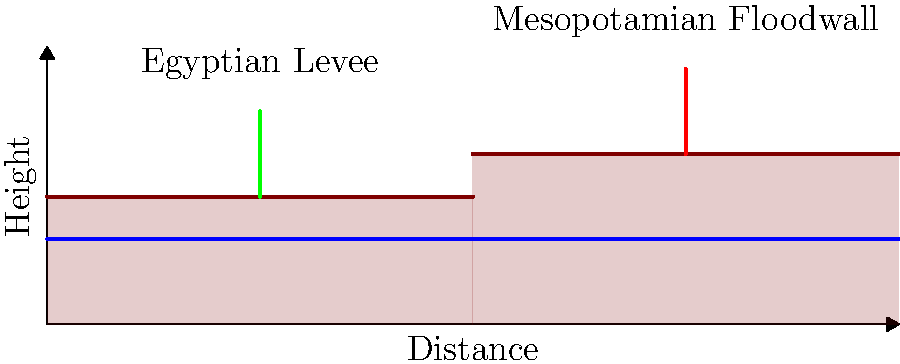Based on the cross-sectional diagram comparing flood control methods of ancient Egyptian and Mesopotamian civilizations, which method appears to be more effective in protecting against higher flood levels, and why might this understanding be important for a historian critically analyzing mythological accounts of ancient floods? To answer this question, let's analyze the diagram step-by-step:

1. Egyptian Levee:
   - Located on the left side of the diagram
   - Built on lower ground (elevation of 30 units)
   - Height of approximately 20 units above the ground

2. Mesopotamian Floodwall:
   - Located on the right side of the diagram
   - Built on higher ground (elevation of 40 units)
   - Height of approximately 20 units above the ground

3. Comparison:
   - The Mesopotamian floodwall reaches a higher overall elevation (60 units) compared to the Egyptian levee (50 units)
   - The water level shown in the diagram is at 20 units

4. Effectiveness analysis:
   - The Mesopotamian floodwall provides protection against higher flood levels due to its higher overall elevation
   - The Egyptian levee, while still effective, would be overtopped by floods that the Mesopotamian floodwall could withstand

5. Importance for historical analysis:
   - Understanding the effectiveness of flood control methods helps contextualize historical accounts and myths about floods
   - It allows historians to critically evaluate the plausibility of flood narratives in different regions
   - Comparing engineering techniques provides insight into the technological capabilities and environmental challenges of ancient civilizations
   - This knowledge can help separate factual historical events from exaggerated or mythologized accounts of floods

6. Critical approach to mythology:
   - By understanding the actual flood control capabilities, historians can assess whether mythological flood accounts are based on real events or are purely symbolic
   - It helps in distinguishing between localized flooding events and exaggerated claims of catastrophic, civilization-ending floods
   - This approach emphasizes the importance of corroborating mythological accounts with archaeological and geological evidence

In conclusion, the Mesopotamian floodwall appears more effective against higher flood levels. This understanding is crucial for historians to critically analyze mythological flood accounts, separating potential historical events from exaggerated narratives, and gaining insight into the technological capabilities of ancient civilizations.
Answer: Mesopotamian floodwall; enables critical analysis of flood myths versus historical reality. 